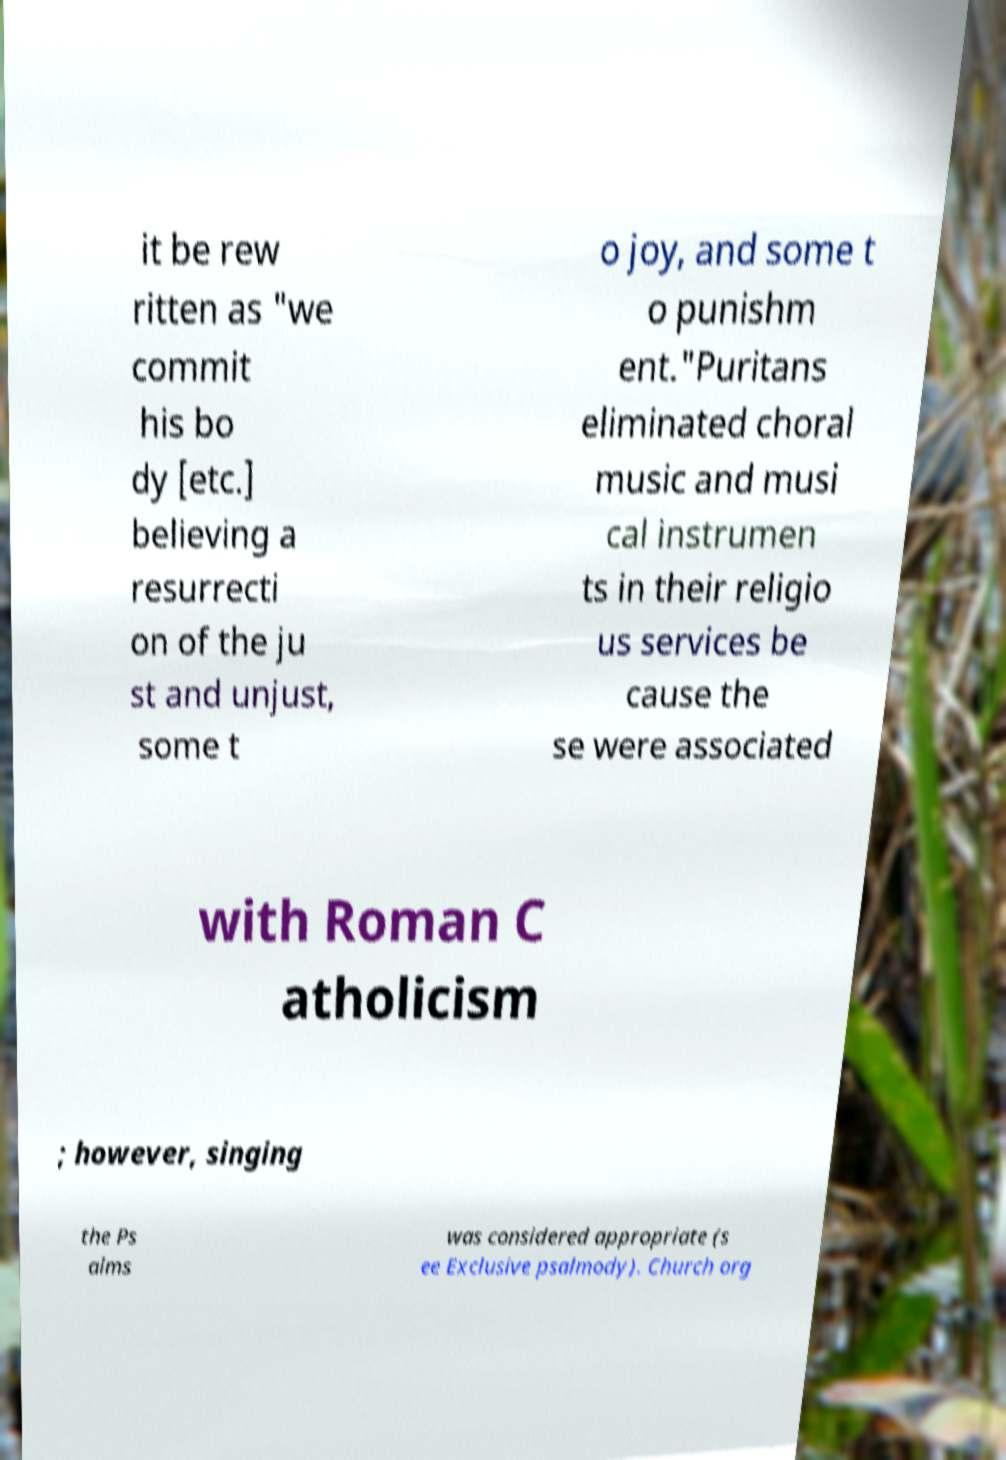For documentation purposes, I need the text within this image transcribed. Could you provide that? it be rew ritten as "we commit his bo dy [etc.] believing a resurrecti on of the ju st and unjust, some t o joy, and some t o punishm ent."Puritans eliminated choral music and musi cal instrumen ts in their religio us services be cause the se were associated with Roman C atholicism ; however, singing the Ps alms was considered appropriate (s ee Exclusive psalmody). Church org 